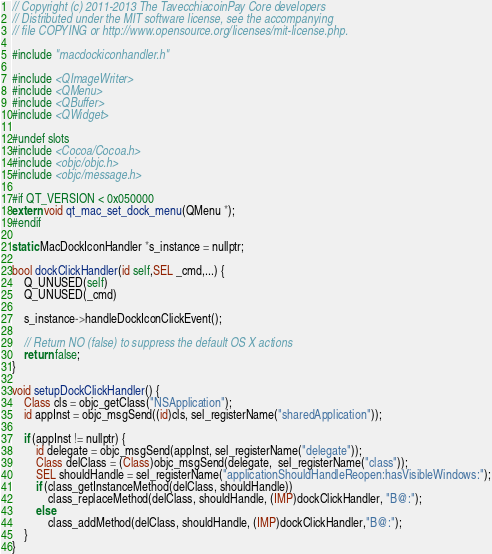Convert code to text. <code><loc_0><loc_0><loc_500><loc_500><_ObjectiveC_>// Copyright (c) 2011-2013 The TavecchiacoinPay Core developers
// Distributed under the MIT software license, see the accompanying
// file COPYING or http://www.opensource.org/licenses/mit-license.php.

#include "macdockiconhandler.h"

#include <QImageWriter>
#include <QMenu>
#include <QBuffer>
#include <QWidget>

#undef slots
#include <Cocoa/Cocoa.h>
#include <objc/objc.h>
#include <objc/message.h>

#if QT_VERSION < 0x050000
extern void qt_mac_set_dock_menu(QMenu *);
#endif

static MacDockIconHandler *s_instance = nullptr;

bool dockClickHandler(id self,SEL _cmd,...) {
    Q_UNUSED(self)
    Q_UNUSED(_cmd)
    
    s_instance->handleDockIconClickEvent();
    
    // Return NO (false) to suppress the default OS X actions
    return false;
}

void setupDockClickHandler() {
    Class cls = objc_getClass("NSApplication");
    id appInst = objc_msgSend((id)cls, sel_registerName("sharedApplication"));
    
    if (appInst != nullptr) {
        id delegate = objc_msgSend(appInst, sel_registerName("delegate"));
        Class delClass = (Class)objc_msgSend(delegate,  sel_registerName("class"));
        SEL shouldHandle = sel_registerName("applicationShouldHandleReopen:hasVisibleWindows:");
        if (class_getInstanceMethod(delClass, shouldHandle))
            class_replaceMethod(delClass, shouldHandle, (IMP)dockClickHandler, "B@:");
        else
            class_addMethod(delClass, shouldHandle, (IMP)dockClickHandler,"B@:");
    }
}

</code> 